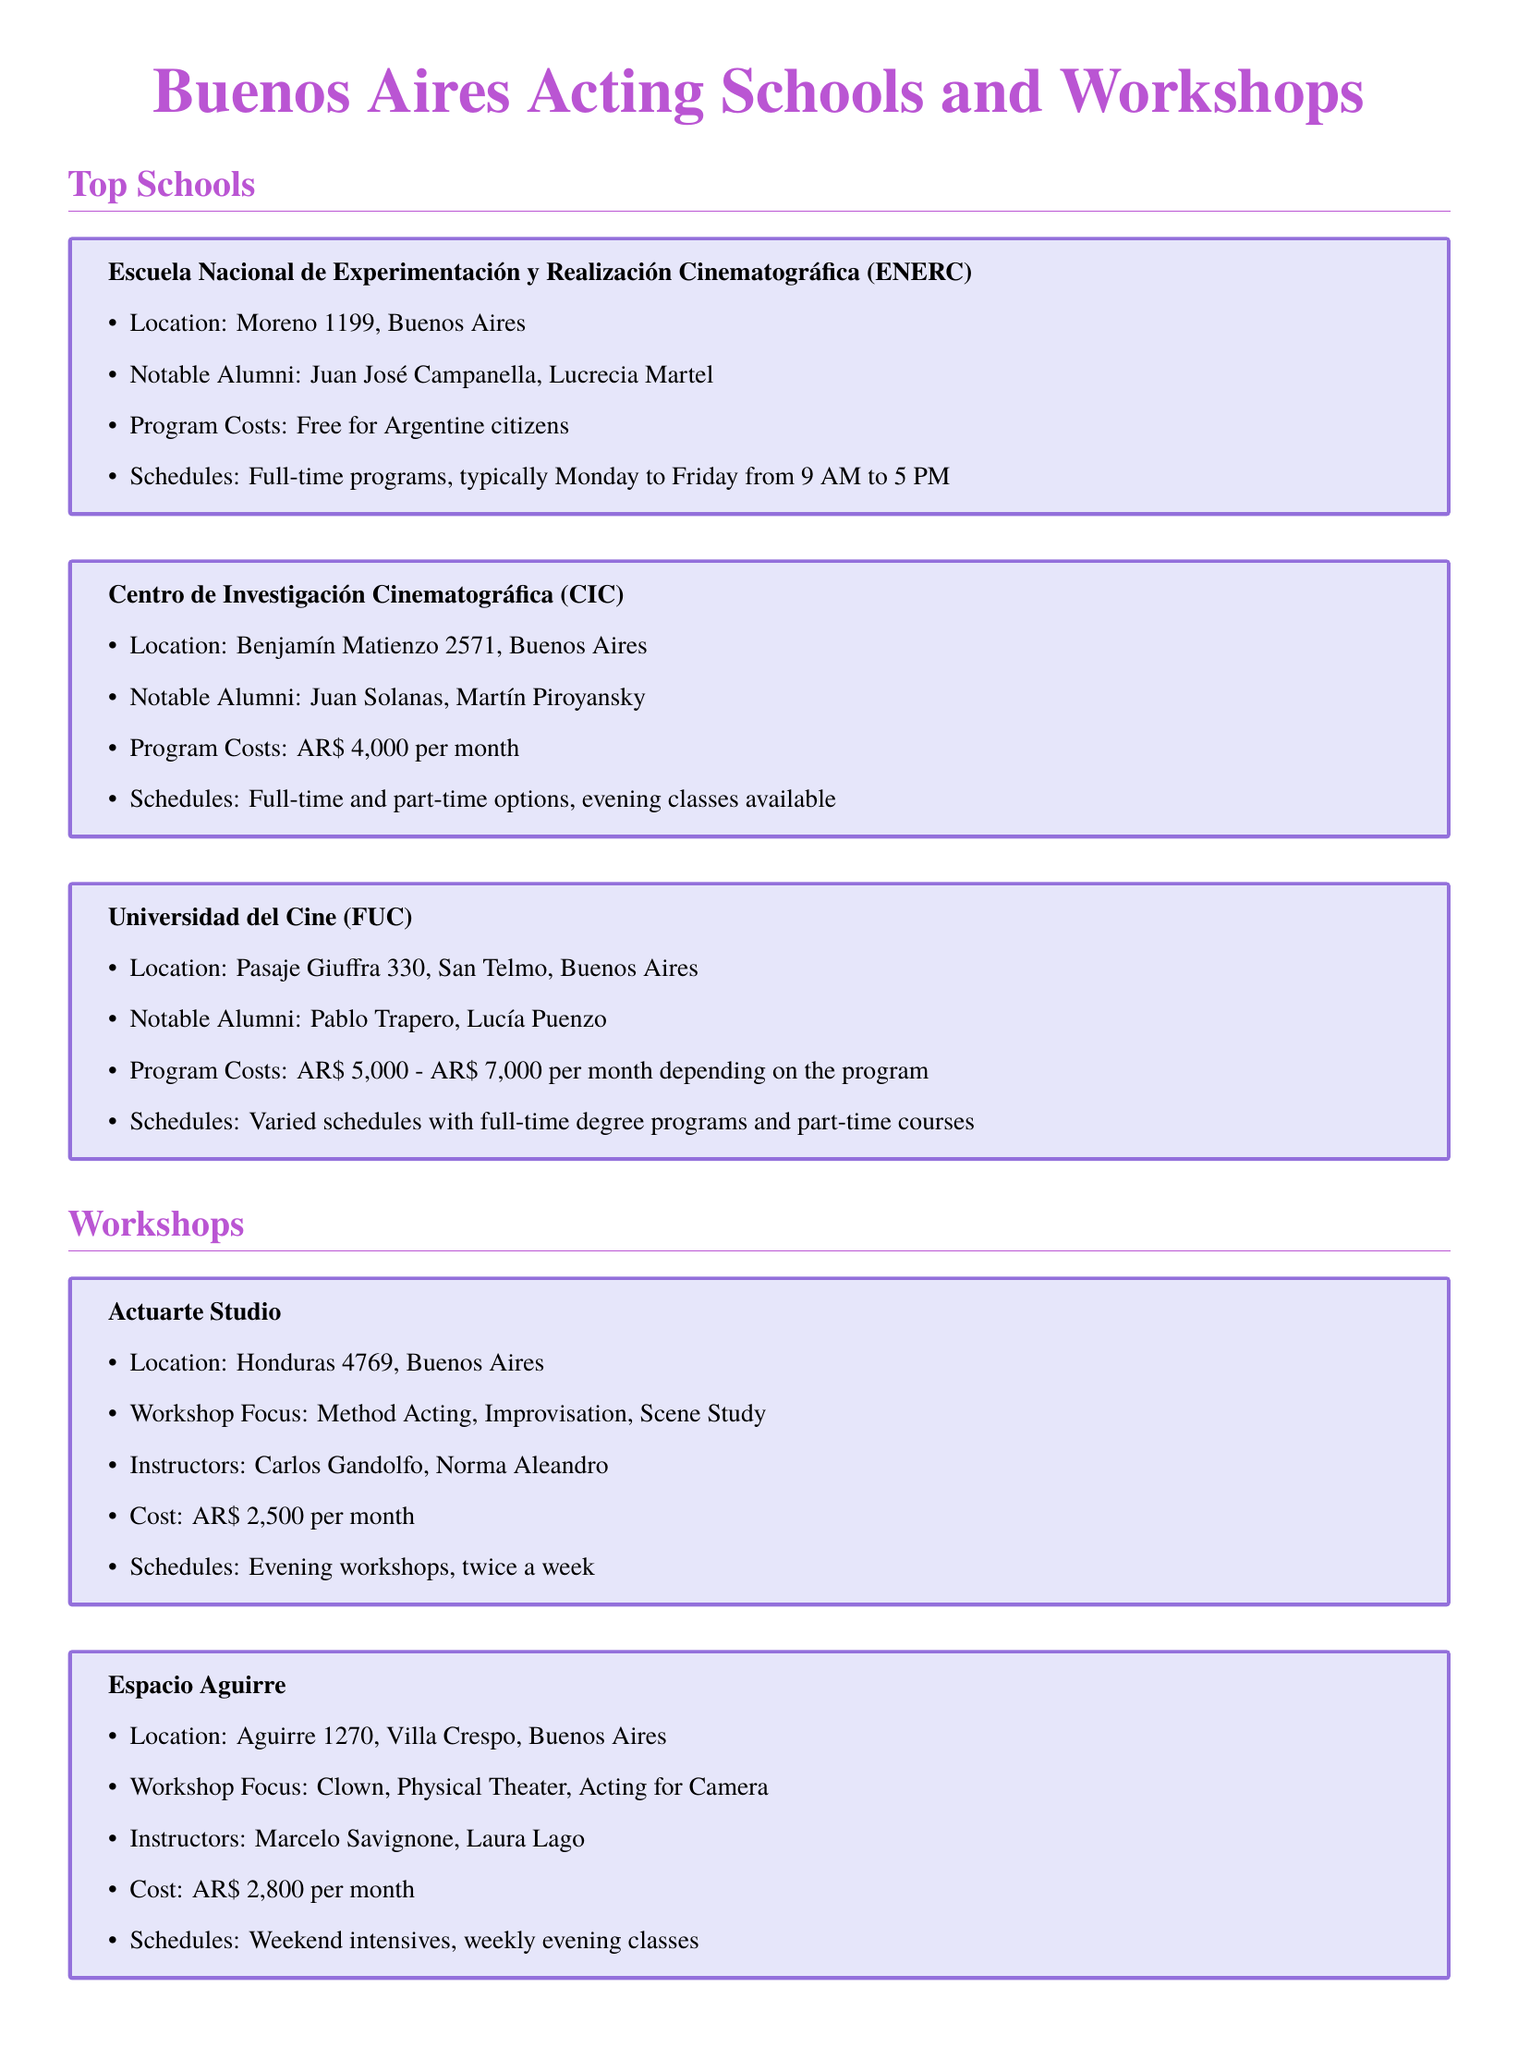What is the location of Escuela Nacional de Experimentación y Realización Cinematográfica? The location is listed in the document as Moreno 1199, Buenos Aires.
Answer: Moreno 1199, Buenos Aires Who are notable alumni of Centro de Investigación Cinematográfica? The document mentions Juan Solanas and Martín Piroyansky as notable alumni.
Answer: Juan Solanas, Martín Piroyansky What is the cost per month for attending Actuarte Studio? The document specifies that the cost is AR$ 2,500 per month for this workshop.
Answer: AR$ 2,500 What acting focus does Espacio Aguirre have? The document highlights that Espacio Aguirre's focus includes Clown, Physical Theater, and Acting for Camera.
Answer: Clown, Physical Theater, Acting for Camera Are full-time programs offered at Universidad del Cine? The document states that Universidad del Cine has full-time degree programs available.
Answer: Yes What kind of scholarships do the institutions offer? The document notes that many institutions offer scholarships or financial aid for students with financial needs or exceptional talent.
Answer: Scholarships or financial aid What days are the workshops at Actuarte Studio held? The document indicates that the workshops are held twice a week in the evening.
Answer: Twice a week How much does the program at Universidad del Cine range from? The document provides a range of AR$ 5,000 to AR$ 7,000 per month for the program costs.
Answer: AR$ 5,000 - AR$ 7,000 What is the schedule type for Centro de Investigación Cinematográfica? The document states that there are full-time and part-time options available, with evening classes.
Answer: Full-time and part-time options, evening classes 